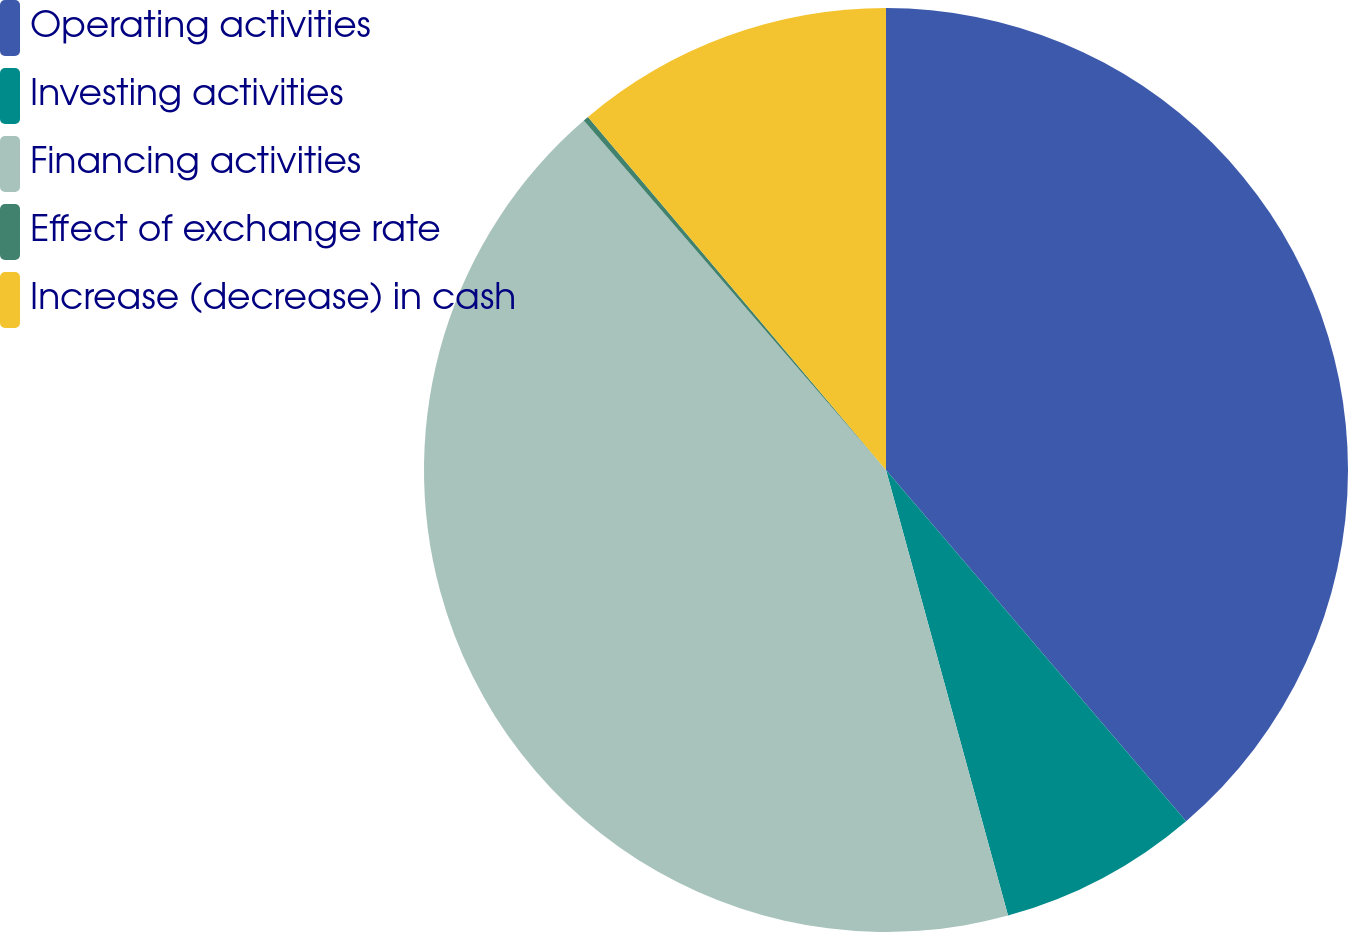<chart> <loc_0><loc_0><loc_500><loc_500><pie_chart><fcel>Operating activities<fcel>Investing activities<fcel>Financing activities<fcel>Effect of exchange rate<fcel>Increase (decrease) in cash<nl><fcel>38.75%<fcel>7.0%<fcel>42.91%<fcel>0.19%<fcel>11.16%<nl></chart> 